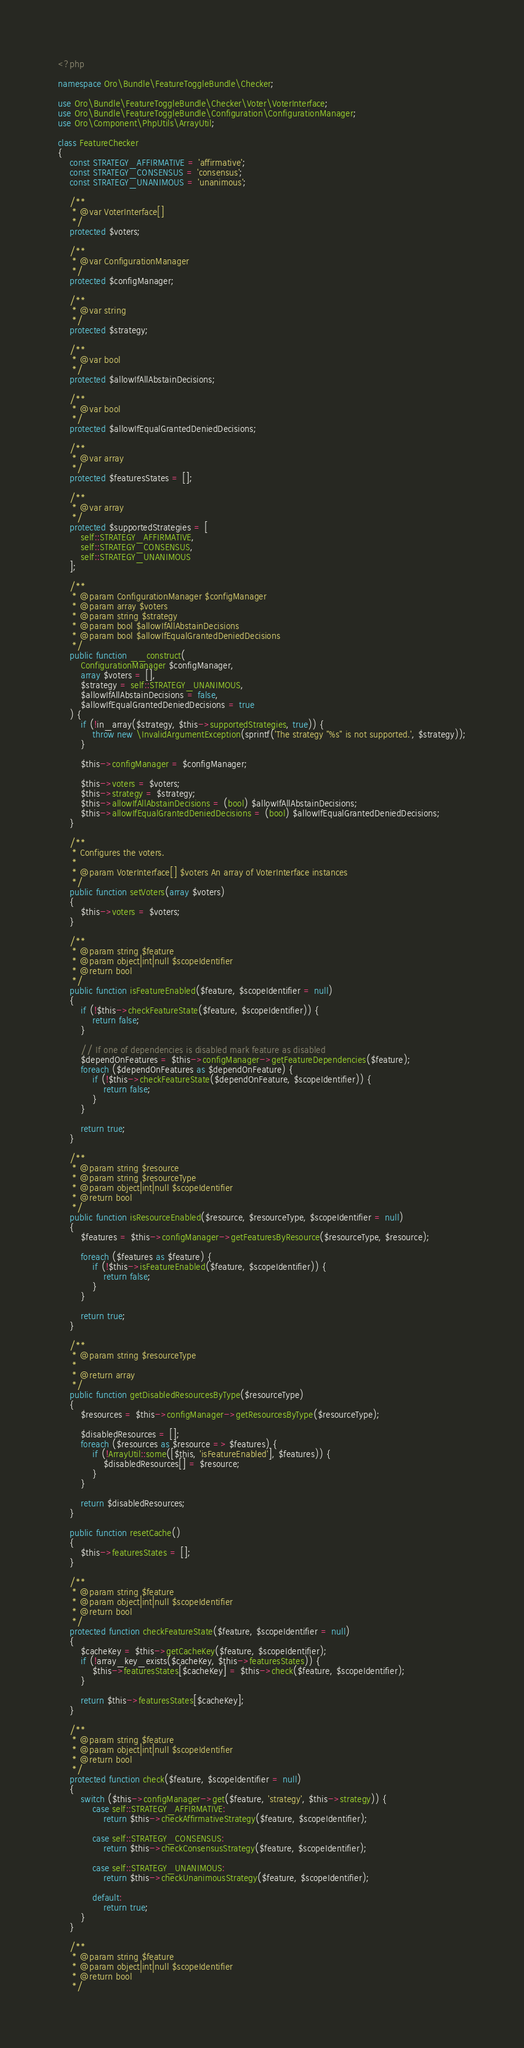Convert code to text. <code><loc_0><loc_0><loc_500><loc_500><_PHP_><?php

namespace Oro\Bundle\FeatureToggleBundle\Checker;

use Oro\Bundle\FeatureToggleBundle\Checker\Voter\VoterInterface;
use Oro\Bundle\FeatureToggleBundle\Configuration\ConfigurationManager;
use Oro\Component\PhpUtils\ArrayUtil;

class FeatureChecker
{
    const STRATEGY_AFFIRMATIVE = 'affirmative';
    const STRATEGY_CONSENSUS = 'consensus';
    const STRATEGY_UNANIMOUS = 'unanimous';

    /**
     * @var VoterInterface[]
     */
    protected $voters;

    /**
     * @var ConfigurationManager
     */
    protected $configManager;

    /**
     * @var string
     */
    protected $strategy;

    /**
     * @var bool
     */
    protected $allowIfAllAbstainDecisions;

    /**
     * @var bool
     */
    protected $allowIfEqualGrantedDeniedDecisions;

    /**
     * @var array
     */
    protected $featuresStates = [];

    /**
     * @var array
     */
    protected $supportedStrategies = [
        self::STRATEGY_AFFIRMATIVE,
        self::STRATEGY_CONSENSUS,
        self::STRATEGY_UNANIMOUS
    ];

    /**
     * @param ConfigurationManager $configManager
     * @param array $voters
     * @param string $strategy
     * @param bool $allowIfAllAbstainDecisions
     * @param bool $allowIfEqualGrantedDeniedDecisions
     */
    public function __construct(
        ConfigurationManager $configManager,
        array $voters = [],
        $strategy = self::STRATEGY_UNANIMOUS,
        $allowIfAllAbstainDecisions = false,
        $allowIfEqualGrantedDeniedDecisions = true
    ) {
        if (!in_array($strategy, $this->supportedStrategies, true)) {
            throw new \InvalidArgumentException(sprintf('The strategy "%s" is not supported.', $strategy));
        }

        $this->configManager = $configManager;

        $this->voters = $voters;
        $this->strategy = $strategy;
        $this->allowIfAllAbstainDecisions = (bool) $allowIfAllAbstainDecisions;
        $this->allowIfEqualGrantedDeniedDecisions = (bool) $allowIfEqualGrantedDeniedDecisions;
    }
    
    /**
     * Configures the voters.
     *
     * @param VoterInterface[] $voters An array of VoterInterface instances
     */
    public function setVoters(array $voters)
    {
        $this->voters = $voters;
    }

    /**
     * @param string $feature
     * @param object|int|null $scopeIdentifier
     * @return bool
     */
    public function isFeatureEnabled($feature, $scopeIdentifier = null)
    {
        if (!$this->checkFeatureState($feature, $scopeIdentifier)) {
            return false;
        }

        // If one of dependencies is disabled mark feature as disabled
        $dependOnFeatures = $this->configManager->getFeatureDependencies($feature);
        foreach ($dependOnFeatures as $dependOnFeature) {
            if (!$this->checkFeatureState($dependOnFeature, $scopeIdentifier)) {
                return false;
            }
        }

        return true;
    }

    /**
     * @param string $resource
     * @param string $resourceType
     * @param object|int|null $scopeIdentifier
     * @return bool
     */
    public function isResourceEnabled($resource, $resourceType, $scopeIdentifier = null)
    {
        $features = $this->configManager->getFeaturesByResource($resourceType, $resource);

        foreach ($features as $feature) {
            if (!$this->isFeatureEnabled($feature, $scopeIdentifier)) {
                return false;
            }
        }

        return true;
    }

    /**
     * @param string $resourceType
     *
     * @return array
     */
    public function getDisabledResourcesByType($resourceType)
    {
        $resources = $this->configManager->getResourcesByType($resourceType);

        $disabledResources = [];
        foreach ($resources as $resource => $features) {
            if (!ArrayUtil::some([$this, 'isFeatureEnabled'], $features)) {
                $disabledResources[] = $resource;
            }
        }

        return $disabledResources;
    }

    public function resetCache()
    {
        $this->featuresStates = [];
    }
    
    /**
     * @param string $feature
     * @param object|int|null $scopeIdentifier
     * @return bool
     */
    protected function checkFeatureState($feature, $scopeIdentifier = null)
    {
        $cacheKey = $this->getCacheKey($feature, $scopeIdentifier);
        if (!array_key_exists($cacheKey, $this->featuresStates)) {
            $this->featuresStates[$cacheKey] = $this->check($feature, $scopeIdentifier);
        }

        return $this->featuresStates[$cacheKey];
    }

    /**
     * @param string $feature
     * @param object|int|null $scopeIdentifier
     * @return bool
     */
    protected function check($feature, $scopeIdentifier = null)
    {
        switch ($this->configManager->get($feature, 'strategy', $this->strategy)) {
            case self::STRATEGY_AFFIRMATIVE:
                return $this->checkAffirmativeStrategy($feature, $scopeIdentifier);

            case self::STRATEGY_CONSENSUS:
                return $this->checkConsensusStrategy($feature, $scopeIdentifier);

            case self::STRATEGY_UNANIMOUS:
                return $this->checkUnanimousStrategy($feature, $scopeIdentifier);

            default:
                return true;
        }
    }

    /**
     * @param string $feature
     * @param object|int|null $scopeIdentifier
     * @return bool
     */</code> 